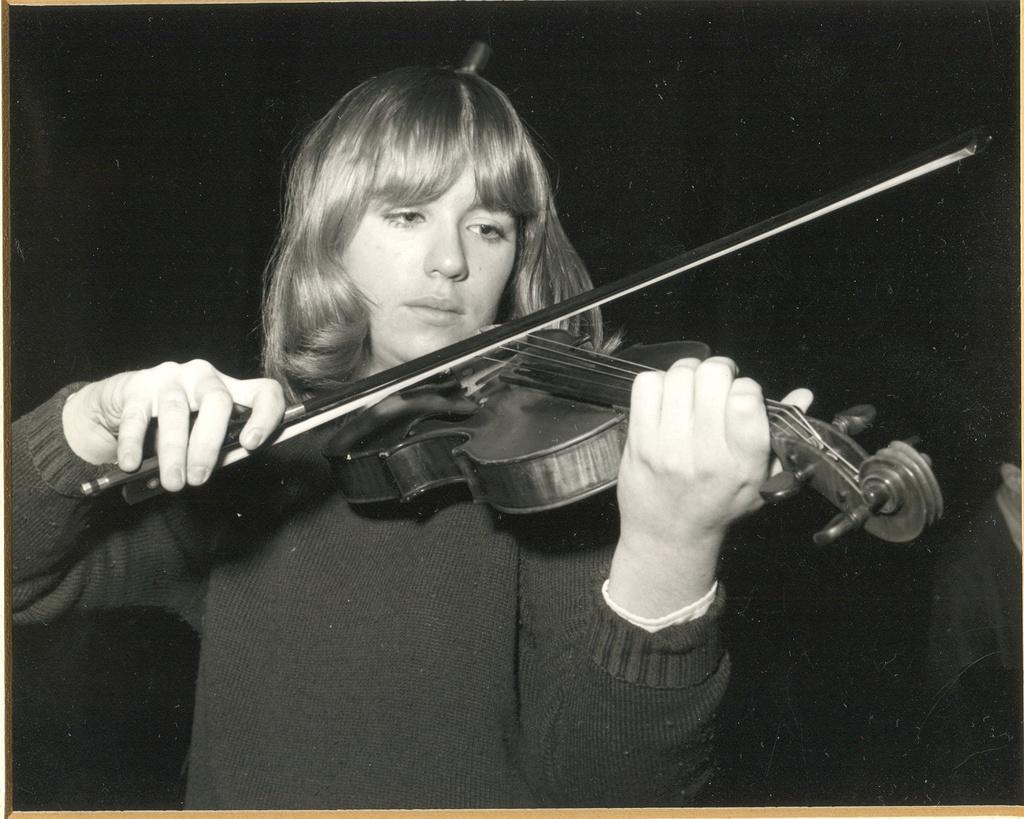Who is the main subject in the image? There is a girl in the image. What is the girl holding in the image? The girl is holding a musical instrument. What is the girl wearing in the image? The girl is wearing a sweater. What can be observed about the background of the image? The background of the image is dark. What type of cough does the girl have in the image? There is no indication of a cough in the image; the girl is holding a musical instrument and wearing a sweater. 